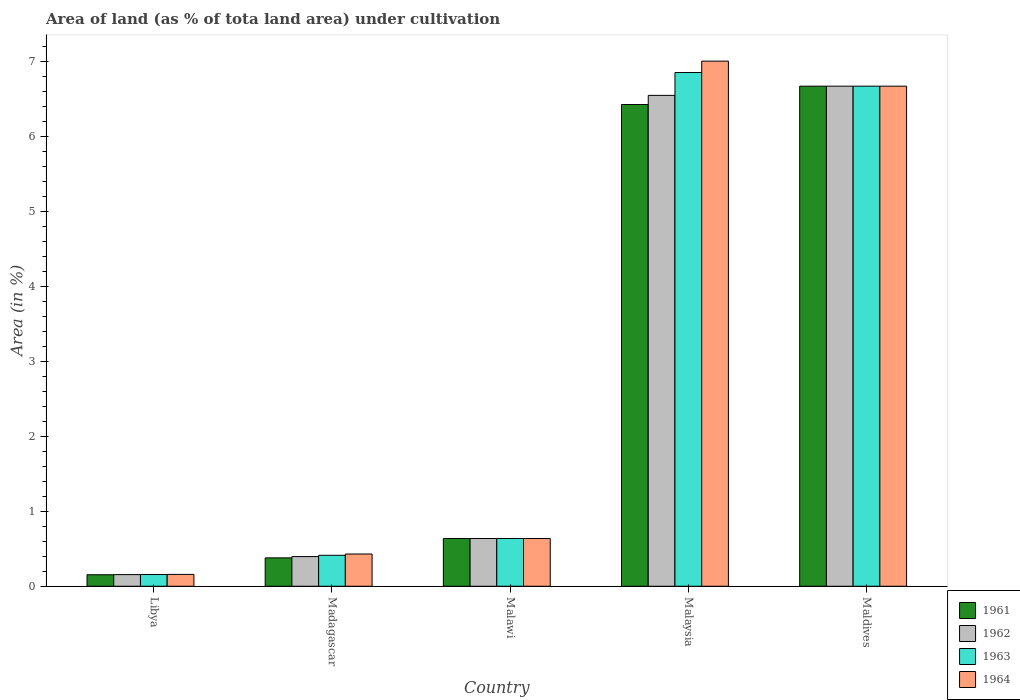How many different coloured bars are there?
Your response must be concise. 4. What is the label of the 2nd group of bars from the left?
Offer a terse response. Madagascar. What is the percentage of land under cultivation in 1963 in Malawi?
Provide a short and direct response. 0.64. Across all countries, what is the maximum percentage of land under cultivation in 1963?
Your response must be concise. 6.85. Across all countries, what is the minimum percentage of land under cultivation in 1961?
Give a very brief answer. 0.15. In which country was the percentage of land under cultivation in 1964 maximum?
Keep it short and to the point. Malaysia. In which country was the percentage of land under cultivation in 1961 minimum?
Provide a short and direct response. Libya. What is the total percentage of land under cultivation in 1963 in the graph?
Offer a very short reply. 14.72. What is the difference between the percentage of land under cultivation in 1963 in Libya and that in Malawi?
Your response must be concise. -0.48. What is the difference between the percentage of land under cultivation in 1961 in Maldives and the percentage of land under cultivation in 1964 in Malawi?
Your answer should be compact. 6.03. What is the average percentage of land under cultivation in 1962 per country?
Ensure brevity in your answer.  2.88. What is the ratio of the percentage of land under cultivation in 1961 in Malawi to that in Maldives?
Make the answer very short. 0.1. What is the difference between the highest and the second highest percentage of land under cultivation in 1962?
Offer a terse response. -6.03. What is the difference between the highest and the lowest percentage of land under cultivation in 1964?
Make the answer very short. 6.84. Is the sum of the percentage of land under cultivation in 1964 in Libya and Malaysia greater than the maximum percentage of land under cultivation in 1962 across all countries?
Your answer should be very brief. Yes. Is it the case that in every country, the sum of the percentage of land under cultivation in 1963 and percentage of land under cultivation in 1962 is greater than the sum of percentage of land under cultivation in 1961 and percentage of land under cultivation in 1964?
Keep it short and to the point. No. What does the 2nd bar from the left in Malawi represents?
Offer a terse response. 1962. Is it the case that in every country, the sum of the percentage of land under cultivation in 1963 and percentage of land under cultivation in 1964 is greater than the percentage of land under cultivation in 1961?
Provide a short and direct response. Yes. What is the difference between two consecutive major ticks on the Y-axis?
Provide a short and direct response. 1. Are the values on the major ticks of Y-axis written in scientific E-notation?
Provide a succinct answer. No. What is the title of the graph?
Give a very brief answer. Area of land (as % of tota land area) under cultivation. What is the label or title of the Y-axis?
Give a very brief answer. Area (in %). What is the Area (in %) of 1961 in Libya?
Your answer should be compact. 0.15. What is the Area (in %) in 1962 in Libya?
Provide a short and direct response. 0.16. What is the Area (in %) in 1963 in Libya?
Ensure brevity in your answer.  0.16. What is the Area (in %) of 1964 in Libya?
Offer a terse response. 0.16. What is the Area (in %) in 1961 in Madagascar?
Your response must be concise. 0.38. What is the Area (in %) in 1962 in Madagascar?
Your answer should be very brief. 0.4. What is the Area (in %) of 1963 in Madagascar?
Keep it short and to the point. 0.41. What is the Area (in %) in 1964 in Madagascar?
Your answer should be very brief. 0.43. What is the Area (in %) in 1961 in Malawi?
Provide a succinct answer. 0.64. What is the Area (in %) in 1962 in Malawi?
Provide a succinct answer. 0.64. What is the Area (in %) of 1963 in Malawi?
Give a very brief answer. 0.64. What is the Area (in %) in 1964 in Malawi?
Provide a succinct answer. 0.64. What is the Area (in %) of 1961 in Malaysia?
Make the answer very short. 6.42. What is the Area (in %) of 1962 in Malaysia?
Provide a succinct answer. 6.54. What is the Area (in %) in 1963 in Malaysia?
Your answer should be compact. 6.85. What is the Area (in %) of 1964 in Malaysia?
Ensure brevity in your answer.  7. What is the Area (in %) in 1961 in Maldives?
Your response must be concise. 6.67. What is the Area (in %) of 1962 in Maldives?
Your response must be concise. 6.67. What is the Area (in %) of 1963 in Maldives?
Offer a terse response. 6.67. What is the Area (in %) of 1964 in Maldives?
Offer a very short reply. 6.67. Across all countries, what is the maximum Area (in %) in 1961?
Your answer should be very brief. 6.67. Across all countries, what is the maximum Area (in %) of 1962?
Give a very brief answer. 6.67. Across all countries, what is the maximum Area (in %) in 1963?
Offer a very short reply. 6.85. Across all countries, what is the maximum Area (in %) of 1964?
Provide a short and direct response. 7. Across all countries, what is the minimum Area (in %) of 1961?
Make the answer very short. 0.15. Across all countries, what is the minimum Area (in %) of 1962?
Provide a short and direct response. 0.16. Across all countries, what is the minimum Area (in %) of 1963?
Give a very brief answer. 0.16. Across all countries, what is the minimum Area (in %) in 1964?
Offer a terse response. 0.16. What is the total Area (in %) in 1961 in the graph?
Offer a terse response. 14.26. What is the total Area (in %) of 1962 in the graph?
Give a very brief answer. 14.4. What is the total Area (in %) in 1963 in the graph?
Provide a short and direct response. 14.72. What is the total Area (in %) in 1964 in the graph?
Offer a terse response. 14.89. What is the difference between the Area (in %) of 1961 in Libya and that in Madagascar?
Make the answer very short. -0.22. What is the difference between the Area (in %) of 1962 in Libya and that in Madagascar?
Your answer should be compact. -0.24. What is the difference between the Area (in %) in 1963 in Libya and that in Madagascar?
Offer a very short reply. -0.26. What is the difference between the Area (in %) in 1964 in Libya and that in Madagascar?
Ensure brevity in your answer.  -0.27. What is the difference between the Area (in %) in 1961 in Libya and that in Malawi?
Offer a very short reply. -0.48. What is the difference between the Area (in %) of 1962 in Libya and that in Malawi?
Provide a short and direct response. -0.48. What is the difference between the Area (in %) in 1963 in Libya and that in Malawi?
Keep it short and to the point. -0.48. What is the difference between the Area (in %) in 1964 in Libya and that in Malawi?
Provide a succinct answer. -0.48. What is the difference between the Area (in %) in 1961 in Libya and that in Malaysia?
Provide a succinct answer. -6.27. What is the difference between the Area (in %) of 1962 in Libya and that in Malaysia?
Your answer should be very brief. -6.39. What is the difference between the Area (in %) of 1963 in Libya and that in Malaysia?
Offer a terse response. -6.69. What is the difference between the Area (in %) in 1964 in Libya and that in Malaysia?
Ensure brevity in your answer.  -6.84. What is the difference between the Area (in %) in 1961 in Libya and that in Maldives?
Your response must be concise. -6.51. What is the difference between the Area (in %) in 1962 in Libya and that in Maldives?
Your response must be concise. -6.51. What is the difference between the Area (in %) of 1963 in Libya and that in Maldives?
Your answer should be very brief. -6.51. What is the difference between the Area (in %) in 1964 in Libya and that in Maldives?
Offer a very short reply. -6.51. What is the difference between the Area (in %) in 1961 in Madagascar and that in Malawi?
Make the answer very short. -0.26. What is the difference between the Area (in %) in 1962 in Madagascar and that in Malawi?
Offer a very short reply. -0.24. What is the difference between the Area (in %) in 1963 in Madagascar and that in Malawi?
Keep it short and to the point. -0.22. What is the difference between the Area (in %) in 1964 in Madagascar and that in Malawi?
Make the answer very short. -0.21. What is the difference between the Area (in %) of 1961 in Madagascar and that in Malaysia?
Your answer should be very brief. -6.04. What is the difference between the Area (in %) in 1962 in Madagascar and that in Malaysia?
Keep it short and to the point. -6.15. What is the difference between the Area (in %) of 1963 in Madagascar and that in Malaysia?
Make the answer very short. -6.44. What is the difference between the Area (in %) of 1964 in Madagascar and that in Malaysia?
Provide a short and direct response. -6.57. What is the difference between the Area (in %) of 1961 in Madagascar and that in Maldives?
Give a very brief answer. -6.29. What is the difference between the Area (in %) in 1962 in Madagascar and that in Maldives?
Your response must be concise. -6.27. What is the difference between the Area (in %) of 1963 in Madagascar and that in Maldives?
Your answer should be very brief. -6.25. What is the difference between the Area (in %) in 1964 in Madagascar and that in Maldives?
Keep it short and to the point. -6.24. What is the difference between the Area (in %) of 1961 in Malawi and that in Malaysia?
Your response must be concise. -5.79. What is the difference between the Area (in %) in 1962 in Malawi and that in Malaysia?
Give a very brief answer. -5.91. What is the difference between the Area (in %) of 1963 in Malawi and that in Malaysia?
Provide a succinct answer. -6.21. What is the difference between the Area (in %) of 1964 in Malawi and that in Malaysia?
Your response must be concise. -6.36. What is the difference between the Area (in %) of 1961 in Malawi and that in Maldives?
Your response must be concise. -6.03. What is the difference between the Area (in %) of 1962 in Malawi and that in Maldives?
Keep it short and to the point. -6.03. What is the difference between the Area (in %) of 1963 in Malawi and that in Maldives?
Keep it short and to the point. -6.03. What is the difference between the Area (in %) in 1964 in Malawi and that in Maldives?
Provide a short and direct response. -6.03. What is the difference between the Area (in %) in 1961 in Malaysia and that in Maldives?
Offer a terse response. -0.24. What is the difference between the Area (in %) of 1962 in Malaysia and that in Maldives?
Your answer should be compact. -0.12. What is the difference between the Area (in %) in 1963 in Malaysia and that in Maldives?
Your answer should be compact. 0.18. What is the difference between the Area (in %) of 1964 in Malaysia and that in Maldives?
Your response must be concise. 0.33. What is the difference between the Area (in %) of 1961 in Libya and the Area (in %) of 1962 in Madagascar?
Your answer should be compact. -0.24. What is the difference between the Area (in %) of 1961 in Libya and the Area (in %) of 1963 in Madagascar?
Your response must be concise. -0.26. What is the difference between the Area (in %) of 1961 in Libya and the Area (in %) of 1964 in Madagascar?
Your response must be concise. -0.28. What is the difference between the Area (in %) of 1962 in Libya and the Area (in %) of 1963 in Madagascar?
Your answer should be very brief. -0.26. What is the difference between the Area (in %) of 1962 in Libya and the Area (in %) of 1964 in Madagascar?
Your response must be concise. -0.27. What is the difference between the Area (in %) of 1963 in Libya and the Area (in %) of 1964 in Madagascar?
Your answer should be very brief. -0.27. What is the difference between the Area (in %) of 1961 in Libya and the Area (in %) of 1962 in Malawi?
Your answer should be compact. -0.48. What is the difference between the Area (in %) of 1961 in Libya and the Area (in %) of 1963 in Malawi?
Your response must be concise. -0.48. What is the difference between the Area (in %) of 1961 in Libya and the Area (in %) of 1964 in Malawi?
Your response must be concise. -0.48. What is the difference between the Area (in %) of 1962 in Libya and the Area (in %) of 1963 in Malawi?
Give a very brief answer. -0.48. What is the difference between the Area (in %) in 1962 in Libya and the Area (in %) in 1964 in Malawi?
Offer a terse response. -0.48. What is the difference between the Area (in %) in 1963 in Libya and the Area (in %) in 1964 in Malawi?
Your answer should be very brief. -0.48. What is the difference between the Area (in %) of 1961 in Libya and the Area (in %) of 1962 in Malaysia?
Offer a very short reply. -6.39. What is the difference between the Area (in %) of 1961 in Libya and the Area (in %) of 1963 in Malaysia?
Keep it short and to the point. -6.69. What is the difference between the Area (in %) in 1961 in Libya and the Area (in %) in 1964 in Malaysia?
Keep it short and to the point. -6.85. What is the difference between the Area (in %) in 1962 in Libya and the Area (in %) in 1963 in Malaysia?
Your answer should be compact. -6.69. What is the difference between the Area (in %) of 1962 in Libya and the Area (in %) of 1964 in Malaysia?
Provide a short and direct response. -6.85. What is the difference between the Area (in %) of 1963 in Libya and the Area (in %) of 1964 in Malaysia?
Your response must be concise. -6.84. What is the difference between the Area (in %) of 1961 in Libya and the Area (in %) of 1962 in Maldives?
Your answer should be very brief. -6.51. What is the difference between the Area (in %) of 1961 in Libya and the Area (in %) of 1963 in Maldives?
Your answer should be compact. -6.51. What is the difference between the Area (in %) of 1961 in Libya and the Area (in %) of 1964 in Maldives?
Make the answer very short. -6.51. What is the difference between the Area (in %) of 1962 in Libya and the Area (in %) of 1963 in Maldives?
Ensure brevity in your answer.  -6.51. What is the difference between the Area (in %) in 1962 in Libya and the Area (in %) in 1964 in Maldives?
Keep it short and to the point. -6.51. What is the difference between the Area (in %) in 1963 in Libya and the Area (in %) in 1964 in Maldives?
Make the answer very short. -6.51. What is the difference between the Area (in %) in 1961 in Madagascar and the Area (in %) in 1962 in Malawi?
Give a very brief answer. -0.26. What is the difference between the Area (in %) in 1961 in Madagascar and the Area (in %) in 1963 in Malawi?
Give a very brief answer. -0.26. What is the difference between the Area (in %) in 1961 in Madagascar and the Area (in %) in 1964 in Malawi?
Offer a very short reply. -0.26. What is the difference between the Area (in %) of 1962 in Madagascar and the Area (in %) of 1963 in Malawi?
Ensure brevity in your answer.  -0.24. What is the difference between the Area (in %) in 1962 in Madagascar and the Area (in %) in 1964 in Malawi?
Offer a very short reply. -0.24. What is the difference between the Area (in %) of 1963 in Madagascar and the Area (in %) of 1964 in Malawi?
Provide a succinct answer. -0.22. What is the difference between the Area (in %) of 1961 in Madagascar and the Area (in %) of 1962 in Malaysia?
Offer a terse response. -6.17. What is the difference between the Area (in %) in 1961 in Madagascar and the Area (in %) in 1963 in Malaysia?
Provide a short and direct response. -6.47. What is the difference between the Area (in %) of 1961 in Madagascar and the Area (in %) of 1964 in Malaysia?
Your answer should be very brief. -6.62. What is the difference between the Area (in %) of 1962 in Madagascar and the Area (in %) of 1963 in Malaysia?
Make the answer very short. -6.45. What is the difference between the Area (in %) in 1962 in Madagascar and the Area (in %) in 1964 in Malaysia?
Your answer should be compact. -6.61. What is the difference between the Area (in %) of 1963 in Madagascar and the Area (in %) of 1964 in Malaysia?
Offer a very short reply. -6.59. What is the difference between the Area (in %) in 1961 in Madagascar and the Area (in %) in 1962 in Maldives?
Provide a succinct answer. -6.29. What is the difference between the Area (in %) of 1961 in Madagascar and the Area (in %) of 1963 in Maldives?
Ensure brevity in your answer.  -6.29. What is the difference between the Area (in %) in 1961 in Madagascar and the Area (in %) in 1964 in Maldives?
Offer a terse response. -6.29. What is the difference between the Area (in %) in 1962 in Madagascar and the Area (in %) in 1963 in Maldives?
Your response must be concise. -6.27. What is the difference between the Area (in %) of 1962 in Madagascar and the Area (in %) of 1964 in Maldives?
Make the answer very short. -6.27. What is the difference between the Area (in %) in 1963 in Madagascar and the Area (in %) in 1964 in Maldives?
Your answer should be very brief. -6.25. What is the difference between the Area (in %) of 1961 in Malawi and the Area (in %) of 1962 in Malaysia?
Your response must be concise. -5.91. What is the difference between the Area (in %) in 1961 in Malawi and the Area (in %) in 1963 in Malaysia?
Provide a succinct answer. -6.21. What is the difference between the Area (in %) of 1961 in Malawi and the Area (in %) of 1964 in Malaysia?
Your answer should be very brief. -6.36. What is the difference between the Area (in %) in 1962 in Malawi and the Area (in %) in 1963 in Malaysia?
Offer a terse response. -6.21. What is the difference between the Area (in %) in 1962 in Malawi and the Area (in %) in 1964 in Malaysia?
Provide a succinct answer. -6.36. What is the difference between the Area (in %) of 1963 in Malawi and the Area (in %) of 1964 in Malaysia?
Keep it short and to the point. -6.36. What is the difference between the Area (in %) in 1961 in Malawi and the Area (in %) in 1962 in Maldives?
Your answer should be compact. -6.03. What is the difference between the Area (in %) in 1961 in Malawi and the Area (in %) in 1963 in Maldives?
Offer a terse response. -6.03. What is the difference between the Area (in %) in 1961 in Malawi and the Area (in %) in 1964 in Maldives?
Offer a terse response. -6.03. What is the difference between the Area (in %) of 1962 in Malawi and the Area (in %) of 1963 in Maldives?
Make the answer very short. -6.03. What is the difference between the Area (in %) of 1962 in Malawi and the Area (in %) of 1964 in Maldives?
Provide a succinct answer. -6.03. What is the difference between the Area (in %) of 1963 in Malawi and the Area (in %) of 1964 in Maldives?
Your response must be concise. -6.03. What is the difference between the Area (in %) in 1961 in Malaysia and the Area (in %) in 1962 in Maldives?
Your response must be concise. -0.24. What is the difference between the Area (in %) of 1961 in Malaysia and the Area (in %) of 1963 in Maldives?
Keep it short and to the point. -0.24. What is the difference between the Area (in %) in 1961 in Malaysia and the Area (in %) in 1964 in Maldives?
Make the answer very short. -0.24. What is the difference between the Area (in %) in 1962 in Malaysia and the Area (in %) in 1963 in Maldives?
Ensure brevity in your answer.  -0.12. What is the difference between the Area (in %) in 1962 in Malaysia and the Area (in %) in 1964 in Maldives?
Provide a short and direct response. -0.12. What is the difference between the Area (in %) of 1963 in Malaysia and the Area (in %) of 1964 in Maldives?
Offer a very short reply. 0.18. What is the average Area (in %) of 1961 per country?
Your answer should be compact. 2.85. What is the average Area (in %) in 1962 per country?
Offer a very short reply. 2.88. What is the average Area (in %) in 1963 per country?
Provide a succinct answer. 2.94. What is the average Area (in %) in 1964 per country?
Your answer should be very brief. 2.98. What is the difference between the Area (in %) of 1961 and Area (in %) of 1962 in Libya?
Ensure brevity in your answer.  -0. What is the difference between the Area (in %) in 1961 and Area (in %) in 1963 in Libya?
Offer a terse response. -0. What is the difference between the Area (in %) in 1961 and Area (in %) in 1964 in Libya?
Offer a very short reply. -0. What is the difference between the Area (in %) of 1962 and Area (in %) of 1963 in Libya?
Provide a short and direct response. -0. What is the difference between the Area (in %) in 1962 and Area (in %) in 1964 in Libya?
Make the answer very short. -0. What is the difference between the Area (in %) in 1963 and Area (in %) in 1964 in Libya?
Provide a succinct answer. -0. What is the difference between the Area (in %) of 1961 and Area (in %) of 1962 in Madagascar?
Give a very brief answer. -0.02. What is the difference between the Area (in %) in 1961 and Area (in %) in 1963 in Madagascar?
Your answer should be very brief. -0.03. What is the difference between the Area (in %) of 1961 and Area (in %) of 1964 in Madagascar?
Your answer should be very brief. -0.05. What is the difference between the Area (in %) of 1962 and Area (in %) of 1963 in Madagascar?
Provide a short and direct response. -0.02. What is the difference between the Area (in %) in 1962 and Area (in %) in 1964 in Madagascar?
Ensure brevity in your answer.  -0.03. What is the difference between the Area (in %) of 1963 and Area (in %) of 1964 in Madagascar?
Make the answer very short. -0.02. What is the difference between the Area (in %) of 1961 and Area (in %) of 1962 in Malawi?
Give a very brief answer. 0. What is the difference between the Area (in %) in 1962 and Area (in %) in 1963 in Malawi?
Offer a very short reply. 0. What is the difference between the Area (in %) in 1962 and Area (in %) in 1964 in Malawi?
Your answer should be very brief. 0. What is the difference between the Area (in %) in 1961 and Area (in %) in 1962 in Malaysia?
Provide a succinct answer. -0.12. What is the difference between the Area (in %) of 1961 and Area (in %) of 1963 in Malaysia?
Offer a very short reply. -0.43. What is the difference between the Area (in %) in 1961 and Area (in %) in 1964 in Malaysia?
Your answer should be compact. -0.58. What is the difference between the Area (in %) of 1962 and Area (in %) of 1963 in Malaysia?
Give a very brief answer. -0.3. What is the difference between the Area (in %) of 1962 and Area (in %) of 1964 in Malaysia?
Your answer should be compact. -0.46. What is the difference between the Area (in %) of 1963 and Area (in %) of 1964 in Malaysia?
Provide a short and direct response. -0.15. What is the difference between the Area (in %) of 1961 and Area (in %) of 1962 in Maldives?
Provide a short and direct response. 0. What is the ratio of the Area (in %) in 1961 in Libya to that in Madagascar?
Keep it short and to the point. 0.41. What is the ratio of the Area (in %) of 1962 in Libya to that in Madagascar?
Provide a succinct answer. 0.39. What is the ratio of the Area (in %) in 1963 in Libya to that in Madagascar?
Your response must be concise. 0.38. What is the ratio of the Area (in %) of 1964 in Libya to that in Madagascar?
Your response must be concise. 0.37. What is the ratio of the Area (in %) of 1961 in Libya to that in Malawi?
Provide a short and direct response. 0.24. What is the ratio of the Area (in %) of 1962 in Libya to that in Malawi?
Provide a short and direct response. 0.24. What is the ratio of the Area (in %) of 1963 in Libya to that in Malawi?
Offer a very short reply. 0.25. What is the ratio of the Area (in %) in 1964 in Libya to that in Malawi?
Provide a succinct answer. 0.25. What is the ratio of the Area (in %) of 1961 in Libya to that in Malaysia?
Ensure brevity in your answer.  0.02. What is the ratio of the Area (in %) of 1962 in Libya to that in Malaysia?
Ensure brevity in your answer.  0.02. What is the ratio of the Area (in %) in 1963 in Libya to that in Malaysia?
Ensure brevity in your answer.  0.02. What is the ratio of the Area (in %) in 1964 in Libya to that in Malaysia?
Your response must be concise. 0.02. What is the ratio of the Area (in %) in 1961 in Libya to that in Maldives?
Your response must be concise. 0.02. What is the ratio of the Area (in %) of 1962 in Libya to that in Maldives?
Your answer should be compact. 0.02. What is the ratio of the Area (in %) in 1963 in Libya to that in Maldives?
Keep it short and to the point. 0.02. What is the ratio of the Area (in %) in 1964 in Libya to that in Maldives?
Your response must be concise. 0.02. What is the ratio of the Area (in %) in 1961 in Madagascar to that in Malawi?
Provide a short and direct response. 0.59. What is the ratio of the Area (in %) in 1962 in Madagascar to that in Malawi?
Your answer should be compact. 0.62. What is the ratio of the Area (in %) of 1963 in Madagascar to that in Malawi?
Ensure brevity in your answer.  0.65. What is the ratio of the Area (in %) of 1964 in Madagascar to that in Malawi?
Give a very brief answer. 0.68. What is the ratio of the Area (in %) of 1961 in Madagascar to that in Malaysia?
Offer a terse response. 0.06. What is the ratio of the Area (in %) of 1962 in Madagascar to that in Malaysia?
Your answer should be compact. 0.06. What is the ratio of the Area (in %) of 1963 in Madagascar to that in Malaysia?
Your answer should be compact. 0.06. What is the ratio of the Area (in %) of 1964 in Madagascar to that in Malaysia?
Keep it short and to the point. 0.06. What is the ratio of the Area (in %) in 1961 in Madagascar to that in Maldives?
Keep it short and to the point. 0.06. What is the ratio of the Area (in %) in 1962 in Madagascar to that in Maldives?
Provide a short and direct response. 0.06. What is the ratio of the Area (in %) of 1963 in Madagascar to that in Maldives?
Give a very brief answer. 0.06. What is the ratio of the Area (in %) in 1964 in Madagascar to that in Maldives?
Offer a very short reply. 0.06. What is the ratio of the Area (in %) in 1961 in Malawi to that in Malaysia?
Your answer should be very brief. 0.1. What is the ratio of the Area (in %) of 1962 in Malawi to that in Malaysia?
Provide a succinct answer. 0.1. What is the ratio of the Area (in %) in 1963 in Malawi to that in Malaysia?
Make the answer very short. 0.09. What is the ratio of the Area (in %) of 1964 in Malawi to that in Malaysia?
Provide a succinct answer. 0.09. What is the ratio of the Area (in %) of 1961 in Malawi to that in Maldives?
Provide a short and direct response. 0.1. What is the ratio of the Area (in %) of 1962 in Malawi to that in Maldives?
Offer a very short reply. 0.1. What is the ratio of the Area (in %) in 1963 in Malawi to that in Maldives?
Offer a terse response. 0.1. What is the ratio of the Area (in %) of 1964 in Malawi to that in Maldives?
Give a very brief answer. 0.1. What is the ratio of the Area (in %) in 1961 in Malaysia to that in Maldives?
Make the answer very short. 0.96. What is the ratio of the Area (in %) in 1962 in Malaysia to that in Maldives?
Provide a short and direct response. 0.98. What is the ratio of the Area (in %) of 1963 in Malaysia to that in Maldives?
Ensure brevity in your answer.  1.03. What is the ratio of the Area (in %) of 1964 in Malaysia to that in Maldives?
Offer a terse response. 1.05. What is the difference between the highest and the second highest Area (in %) of 1961?
Make the answer very short. 0.24. What is the difference between the highest and the second highest Area (in %) of 1962?
Provide a succinct answer. 0.12. What is the difference between the highest and the second highest Area (in %) of 1963?
Make the answer very short. 0.18. What is the difference between the highest and the second highest Area (in %) in 1964?
Offer a terse response. 0.33. What is the difference between the highest and the lowest Area (in %) of 1961?
Give a very brief answer. 6.51. What is the difference between the highest and the lowest Area (in %) of 1962?
Your answer should be compact. 6.51. What is the difference between the highest and the lowest Area (in %) of 1963?
Give a very brief answer. 6.69. What is the difference between the highest and the lowest Area (in %) in 1964?
Keep it short and to the point. 6.84. 